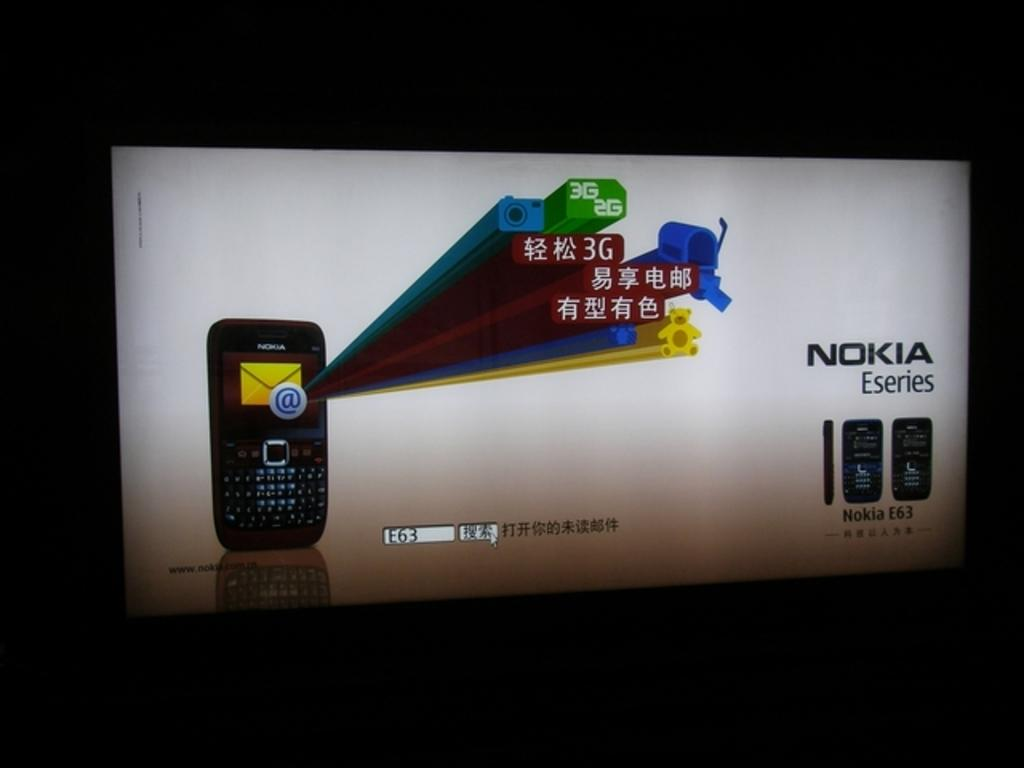<image>
Create a compact narrative representing the image presented. An advertisement for Nokia Eseries is displayed on a screen. 